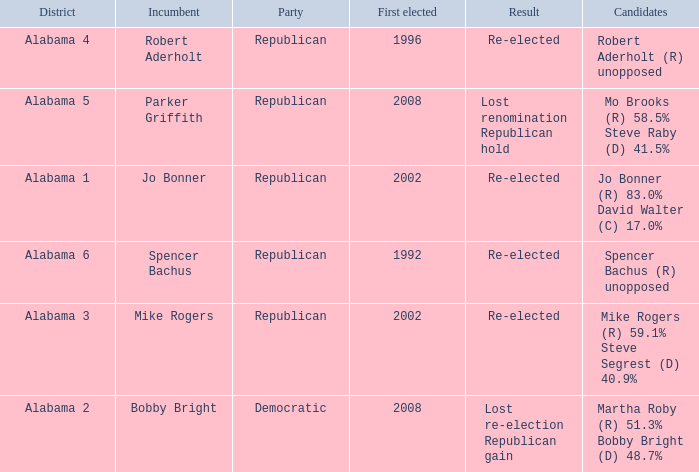Name the incumbent for lost renomination republican hold Parker Griffith. 